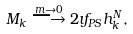<formula> <loc_0><loc_0><loc_500><loc_500>M _ { k } \stackrel { m \rightarrow 0 } { \longrightarrow } 2 \imath f _ { P S } h _ { k } ^ { N } ,</formula> 